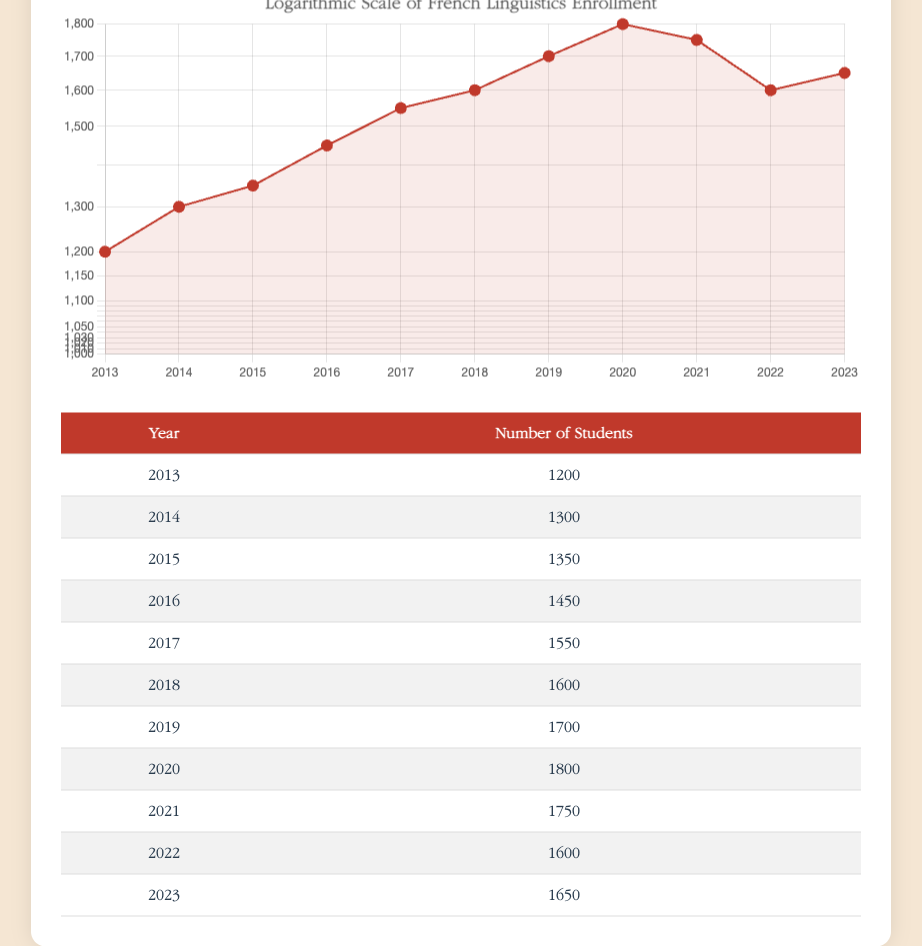What was the enrollment number for the year 2019? Referring to the table, the enrollment number specifically listed for the year 2019 is 1700.
Answer: 1700 What is the highest enrollment number recorded in the table? By examining the data, the highest enrollment number is found in the year 2020, which is 1800.
Answer: 1800 What is the difference in enrollment numbers between 2016 and 2021? To find the difference, we take the enrollment number for 2016 (1450) and subtract the enrollment number for 2021 (1750), resulting in 1750 - 1450 = 300.
Answer: 300 Is the enrollment number for 2022 greater than 2020? Checking the table, the enrollment number for 2022 is 1600, which is less than the number for 2020, which is 1800. Therefore, the statement is false.
Answer: No What was the average enrollment from 2013 to 2015? First, we sum the enrollment numbers for these years: 1200 + 1300 + 1350 = 3850. Then, we divide by the number of years (3) to get the average, which is 3850 / 3 = 1283.33.
Answer: 1283.33 Which year experienced a decline in the enrollment compared to the previous year? By reviewing the annual numbers, in 2021 the enrollment decreased from 1800 (2020) to 1750, and again in 2022 it decreased from 1750 (2021) to 1600.
Answer: 2021 and 2022 What was the enrollment trend from 2013 to 2018? Observing the numbers, from 2013 (1200) to 2018 (1600) there is a consistent increase each year: 1200, 1300, 1350, 1450, 1550, and finally 1600 in 2018. Hence, the trend is upward.
Answer: Upward How many more students were enrolled in 2020 compared to 2013? The enrollment in 2020 is 1800, and in 2013 it was 1200. The difference is 1800 - 1200 = 600.
Answer: 600 Was there a drop in enrollment numbers in 2022 compared to the previous year? Yes, in 2021 the enrollment was 1750 and dropped to 1600 in 2022, indicating a decrease.
Answer: Yes 